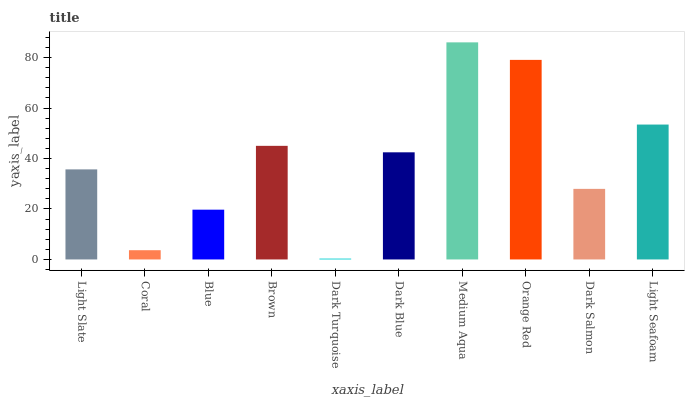Is Coral the minimum?
Answer yes or no. No. Is Coral the maximum?
Answer yes or no. No. Is Light Slate greater than Coral?
Answer yes or no. Yes. Is Coral less than Light Slate?
Answer yes or no. Yes. Is Coral greater than Light Slate?
Answer yes or no. No. Is Light Slate less than Coral?
Answer yes or no. No. Is Dark Blue the high median?
Answer yes or no. Yes. Is Light Slate the low median?
Answer yes or no. Yes. Is Coral the high median?
Answer yes or no. No. Is Coral the low median?
Answer yes or no. No. 